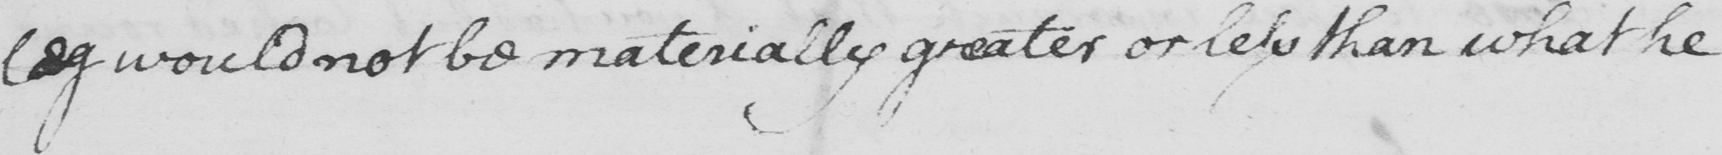Please provide the text content of this handwritten line. leg would not be materially greater or less than what he 